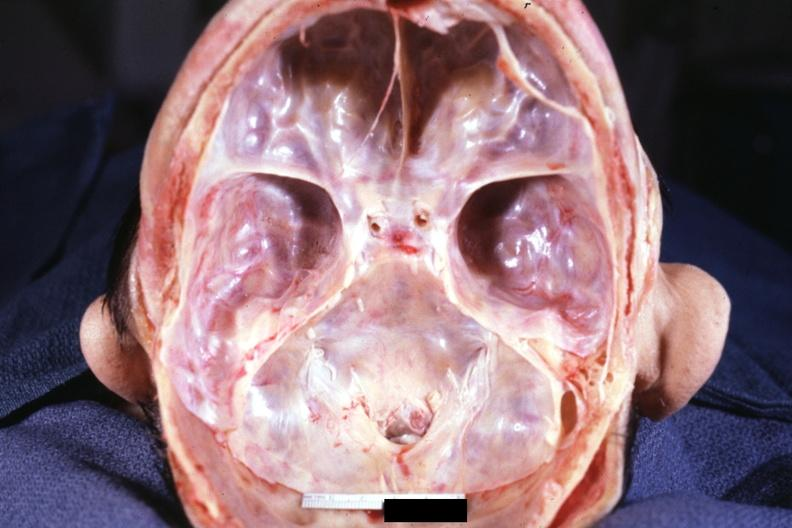s marfans syndrome present?
Answer the question using a single word or phrase. No 